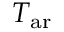<formula> <loc_0><loc_0><loc_500><loc_500>T _ { a r }</formula> 